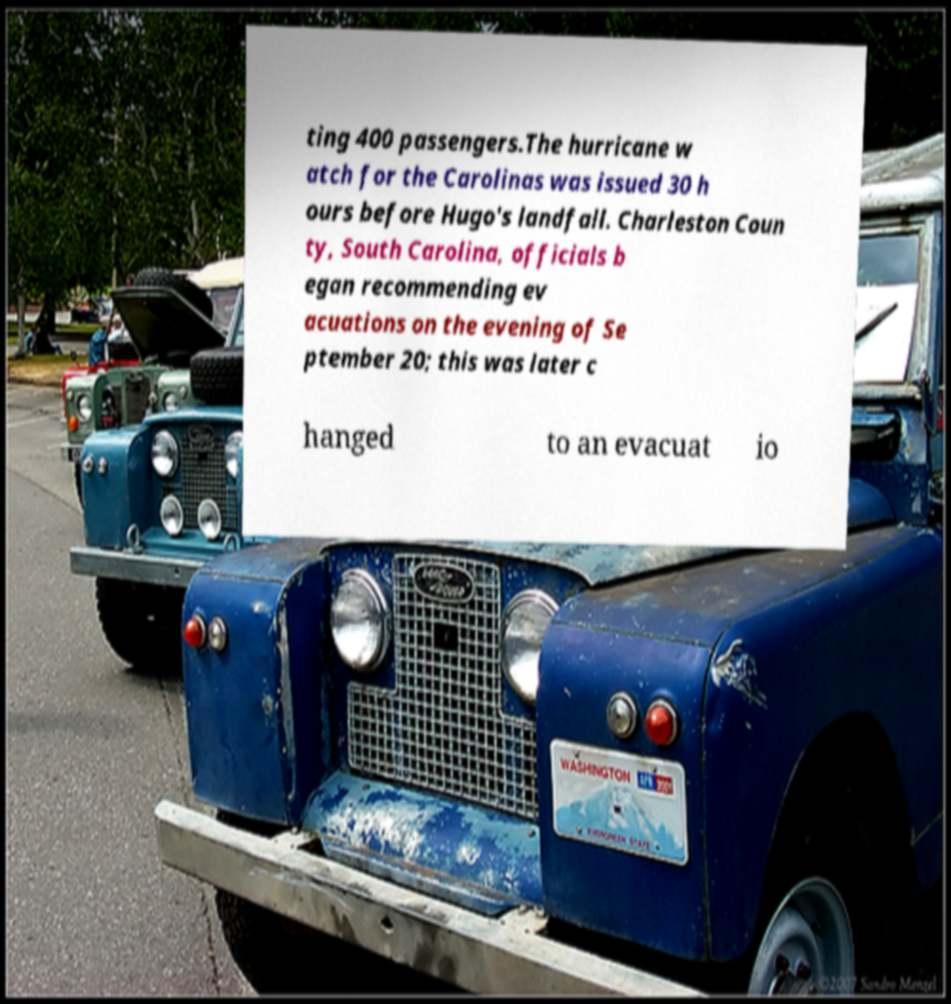I need the written content from this picture converted into text. Can you do that? ting 400 passengers.The hurricane w atch for the Carolinas was issued 30 h ours before Hugo's landfall. Charleston Coun ty, South Carolina, officials b egan recommending ev acuations on the evening of Se ptember 20; this was later c hanged to an evacuat io 